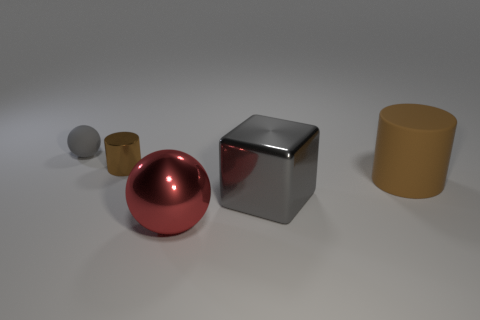Is the number of big metal objects behind the red ball greater than the number of cylinders behind the gray ball?
Your response must be concise. Yes. What number of cylinders are brown shiny objects or brown rubber objects?
Make the answer very short. 2. How many cylinders are to the left of the rubber object in front of the thing behind the tiny brown metallic thing?
Offer a terse response. 1. There is a large object that is the same color as the tiny matte sphere; what material is it?
Your answer should be very brief. Metal. Is the number of gray balls greater than the number of big brown metallic spheres?
Give a very brief answer. Yes. Do the gray matte thing and the red shiny ball have the same size?
Provide a short and direct response. No. What number of objects are rubber cylinders or cubes?
Ensure brevity in your answer.  2. What shape is the gray thing that is to the right of the metal object behind the matte object that is in front of the small brown metal cylinder?
Keep it short and to the point. Cube. Does the gray thing that is to the right of the small gray ball have the same material as the ball in front of the small gray rubber ball?
Make the answer very short. Yes. There is a large red object that is the same shape as the tiny rubber object; what is its material?
Your response must be concise. Metal. 